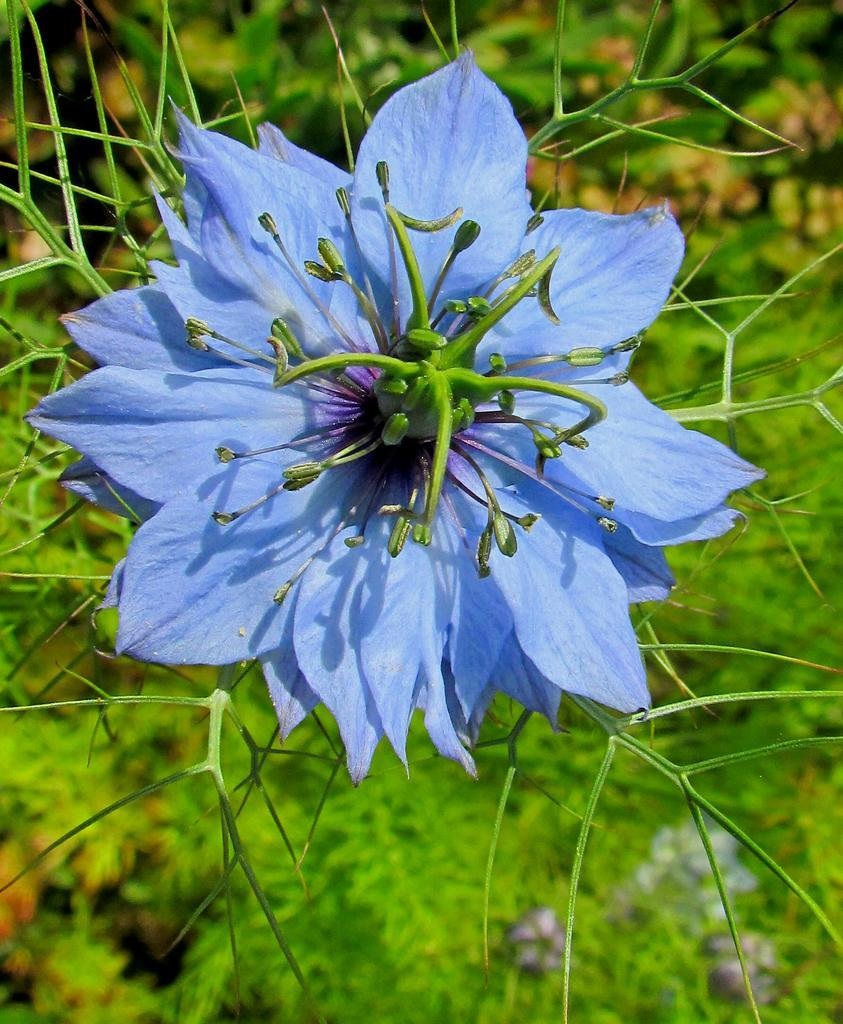What is the main subject of the picture? The main subject of the picture is a flower. Can you describe the flower's attachment in the image? The flower is attached to a plant. What else can be seen in the background of the image? There are other plants visible in the background of the image. Can you see a nest in the image? There is no nest present in the image. 